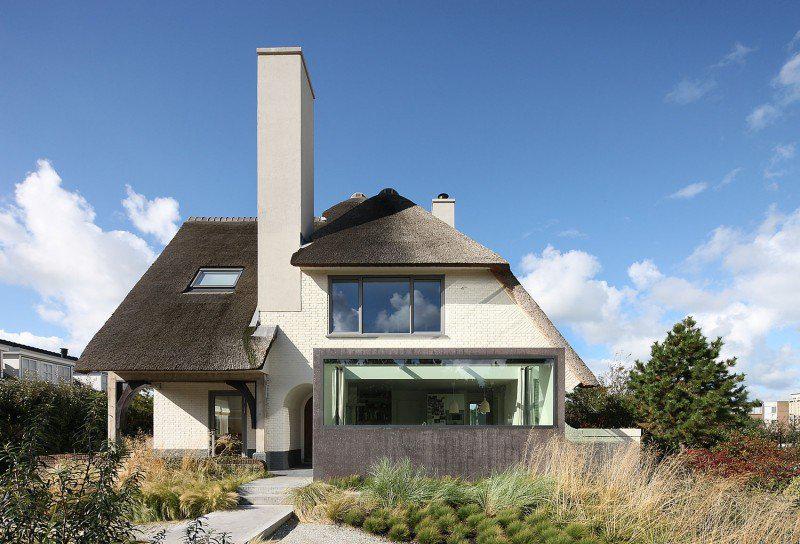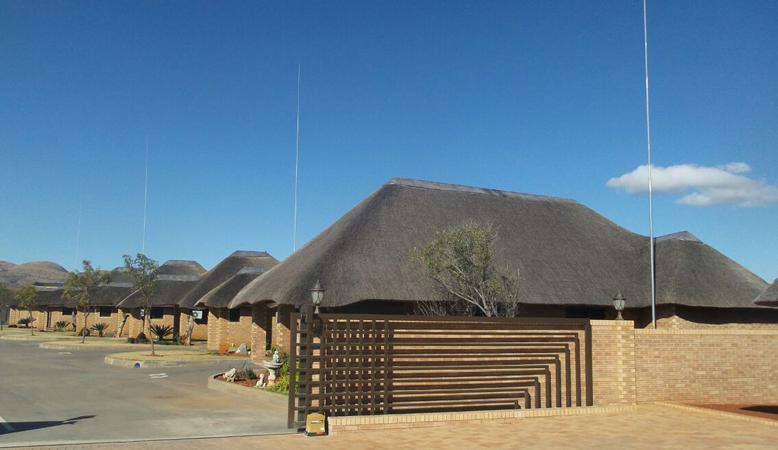The first image is the image on the left, the second image is the image on the right. Considering the images on both sides, is "One of the houses has at least one chimney." valid? Answer yes or no. Yes. The first image is the image on the left, the second image is the image on the right. For the images shown, is this caption "The left and right image contains the same number of of poles to the to one side of the house." true? Answer yes or no. No. 